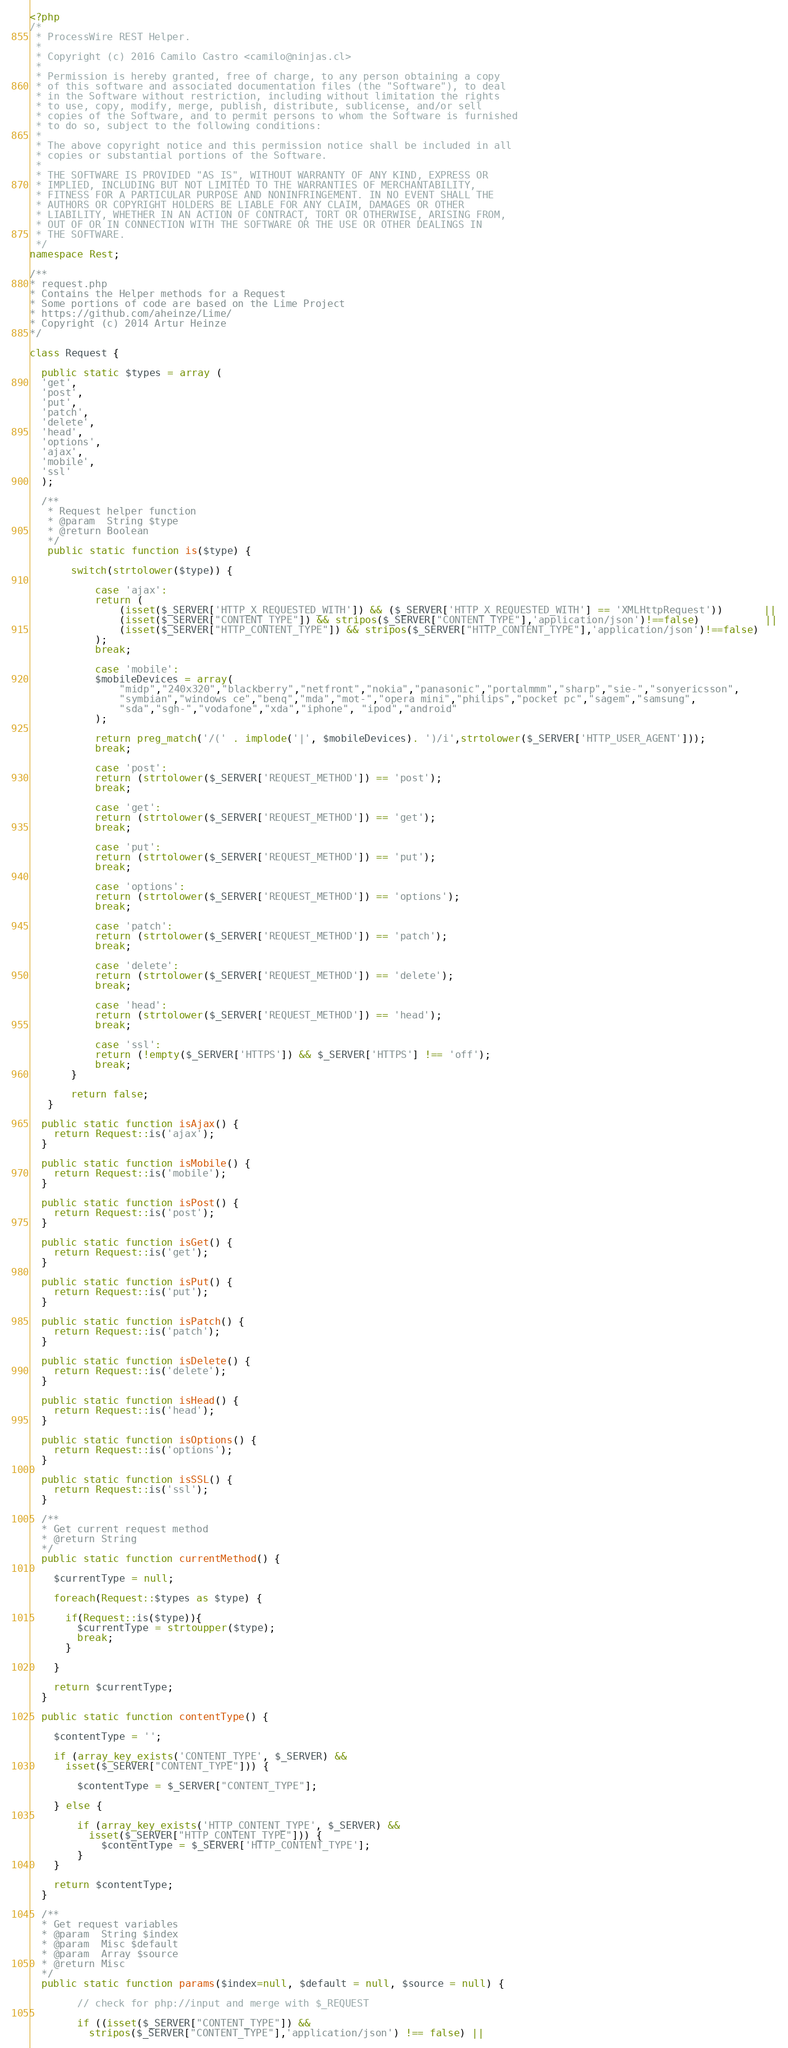<code> <loc_0><loc_0><loc_500><loc_500><_PHP_><?php
/*
 * ProcessWire REST Helper.
 *
 * Copyright (c) 2016 Camilo Castro <camilo@ninjas.cl>
 *
 * Permission is hereby granted, free of charge, to any person obtaining a copy
 * of this software and associated documentation files (the "Software"), to deal
 * in the Software without restriction, including without limitation the rights
 * to use, copy, modify, merge, publish, distribute, sublicense, and/or sell
 * copies of the Software, and to permit persons to whom the Software is furnished
 * to do so, subject to the following conditions:
 *
 * The above copyright notice and this permission notice shall be included in all
 * copies or substantial portions of the Software.
 *
 * THE SOFTWARE IS PROVIDED "AS IS", WITHOUT WARRANTY OF ANY KIND, EXPRESS OR
 * IMPLIED, INCLUDING BUT NOT LIMITED TO THE WARRANTIES OF MERCHANTABILITY,
 * FITNESS FOR A PARTICULAR PURPOSE AND NONINFRINGEMENT. IN NO EVENT SHALL THE
 * AUTHORS OR COPYRIGHT HOLDERS BE LIABLE FOR ANY CLAIM, DAMAGES OR OTHER
 * LIABILITY, WHETHER IN AN ACTION OF CONTRACT, TORT OR OTHERWISE, ARISING FROM,
 * OUT OF OR IN CONNECTION WITH THE SOFTWARE OR THE USE OR OTHER DEALINGS IN
 * THE SOFTWARE.
 */
namespace Rest;

/**
* request.php
* Contains the Helper methods for a Request
* Some portions of code are based on the Lime Project
* https://github.com/aheinze/Lime/
* Copyright (c) 2014 Artur Heinze
*/

class Request {

  public static $types = array (
  'get', 
  'post', 
  'put', 
  'patch', 
  'delete',
  'head', 
  'options', 
  'ajax', 
  'mobile', 
  'ssl'
  );

  /**
   * Request helper function
   * @param  String $type
   * @return Boolean
   */
   public static function is($type) {

       switch(strtolower($type)) {

           case 'ajax':
           return (
               (isset($_SERVER['HTTP_X_REQUESTED_WITH']) && ($_SERVER['HTTP_X_REQUESTED_WITH'] == 'XMLHttpRequest'))       ||
               (isset($_SERVER["CONTENT_TYPE"]) && stripos($_SERVER["CONTENT_TYPE"],'application/json')!==false)           ||
               (isset($_SERVER["HTTP_CONTENT_TYPE"]) && stripos($_SERVER["HTTP_CONTENT_TYPE"],'application/json')!==false)
           );
           break;
           
           case 'mobile':
           $mobileDevices = array(
               "midp","240x320","blackberry","netfront","nokia","panasonic","portalmmm","sharp","sie-","sonyericsson",
               "symbian","windows ce","benq","mda","mot-","opera mini","philips","pocket pc","sagem","samsung",
               "sda","sgh-","vodafone","xda","iphone", "ipod","android"
           );
           
           return preg_match('/(' . implode('|', $mobileDevices). ')/i',strtolower($_SERVER['HTTP_USER_AGENT']));
           break;
           
           case 'post':
           return (strtolower($_SERVER['REQUEST_METHOD']) == 'post');
           break;
           
           case 'get':
           return (strtolower($_SERVER['REQUEST_METHOD']) == 'get');
           break;
           
           case 'put':
           return (strtolower($_SERVER['REQUEST_METHOD']) == 'put');
           break;

           case 'options':
           return (strtolower($_SERVER['REQUEST_METHOD']) == 'options');
           break;

           case 'patch':
           return (strtolower($_SERVER['REQUEST_METHOD']) == 'patch');
           break;
           
           case 'delete':
           return (strtolower($_SERVER['REQUEST_METHOD']) == 'delete');
           break;

           case 'head':
           return (strtolower($_SERVER['REQUEST_METHOD']) == 'head');
           break;
           
           case 'ssl':
           return (!empty($_SERVER['HTTPS']) && $_SERVER['HTTPS'] !== 'off');
           break;
       }

       return false;
   }

  public static function isAjax() {
    return Request::is('ajax');
  }

  public static function isMobile() {
    return Request::is('mobile');
  }

  public static function isPost() {
    return Request::is('post');
  }

  public static function isGet() {
    return Request::is('get');
  }

  public static function isPut() {
    return Request::is('put');
  }

  public static function isPatch() {
    return Request::is('patch');
  }

  public static function isDelete() {
    return Request::is('delete');
  }

  public static function isHead() {
    return Request::is('head');
  }

  public static function isOptions() {
    return Request::is('options');
  }

  public static function isSSL() {
    return Request::is('ssl');
  }

  /**
  * Get current request method
  * @return String
  */
  public static function currentMethod() {
    
    $currentType = null;

    foreach(Request::$types as $type) {
    
      if(Request::is($type)){
        $currentType = strtoupper($type);
        break;
      }

    }

    return $currentType;
  }

  public static function contentType() {
    
    $contentType = '';

    if (array_key_exists('CONTENT_TYPE', $_SERVER) && 
      isset($_SERVER["CONTENT_TYPE"])) {
    
        $contentType = $_SERVER["CONTENT_TYPE"];
    
    } else {
        
        if (array_key_exists('HTTP_CONTENT_TYPE', $_SERVER) && 
          isset($_SERVER["HTTP_CONTENT_TYPE"])) {
            $contentType = $_SERVER['HTTP_CONTENT_TYPE'];
        }
    }

    return $contentType;
  }

  /**
  * Get request variables
  * @param  String $index
  * @param  Misc $default
  * @param  Array $source
  * @return Misc
  */
  public static function params($index=null, $default = null, $source = null) {

        // check for php://input and merge with $_REQUEST
    
        if ((isset($_SERVER["CONTENT_TYPE"]) && 
  		  stripos($_SERVER["CONTENT_TYPE"],'application/json') !== false) ||</code> 